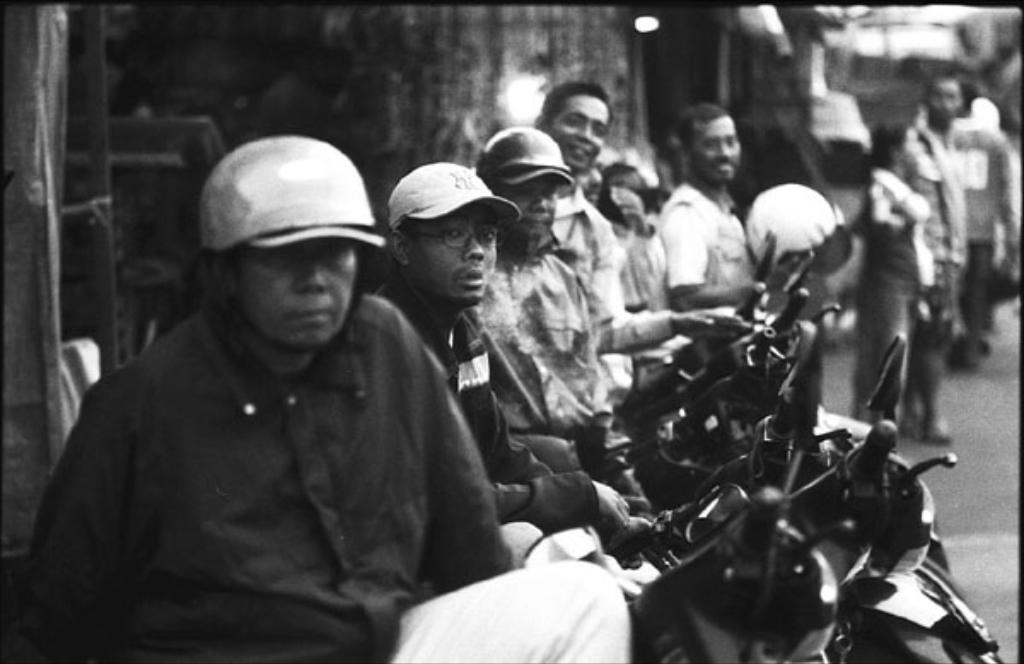What is the color scheme of the image? The image is black and white. What can be seen in the image? There are people in the image. What are some of the people doing in the image? Some people are sitting on motorbikes, while others are standing. Can you describe the background of the image? The background is blurred. What type of pollution is visible in the image? There is no visible pollution in the image, as it is a black and white image with people and motorbikes. Is there a box present in the image? There is no box visible in the image. 